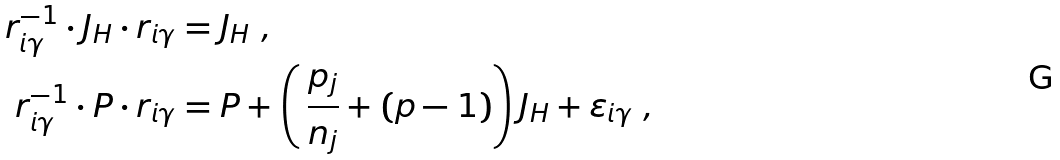<formula> <loc_0><loc_0><loc_500><loc_500>r _ { i \gamma } ^ { - 1 } \cdot J _ { H } \cdot r _ { i \gamma } & = J _ { H } \ , \\ r _ { i \gamma } ^ { - 1 } \cdot P \cdot r _ { i \gamma } & = P + \left ( \, \frac { p _ { j } } { n _ { j } } + ( p - 1 ) \right ) J _ { H } + \varepsilon _ { i \gamma } \ ,</formula> 